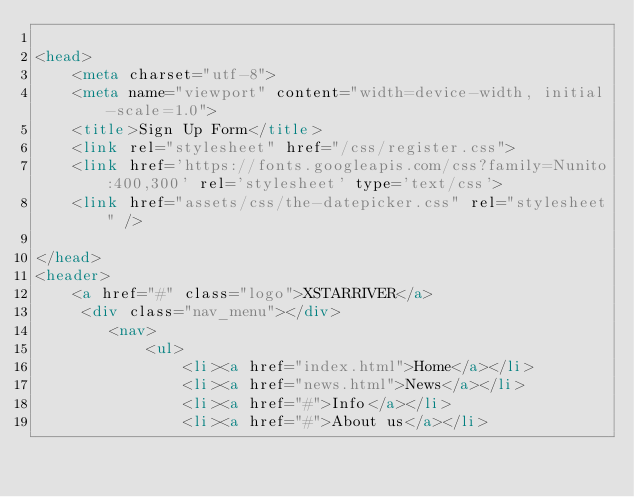Convert code to text. <code><loc_0><loc_0><loc_500><loc_500><_HTML_>
<head>
    <meta charset="utf-8">
    <meta name="viewport" content="width=device-width, initial-scale=1.0">
    <title>Sign Up Form</title>
    <link rel="stylesheet" href="/css/register.css">
    <link href='https://fonts.googleapis.com/css?family=Nunito:400,300' rel='stylesheet' type='text/css'>
    <link href="assets/css/the-datepicker.css" rel="stylesheet" />

</head>
<header> 
    <a href="#" class="logo">XSTARRIVER</a>
     <div class="nav_menu"></div>
        <nav>
            <ul>
                <li><a href="index.html">Home</a></li>
                <li><a href="news.html">News</a></li>
                <li><a href="#">Info</a></li>
                <li><a href="#">About us</a></li></code> 